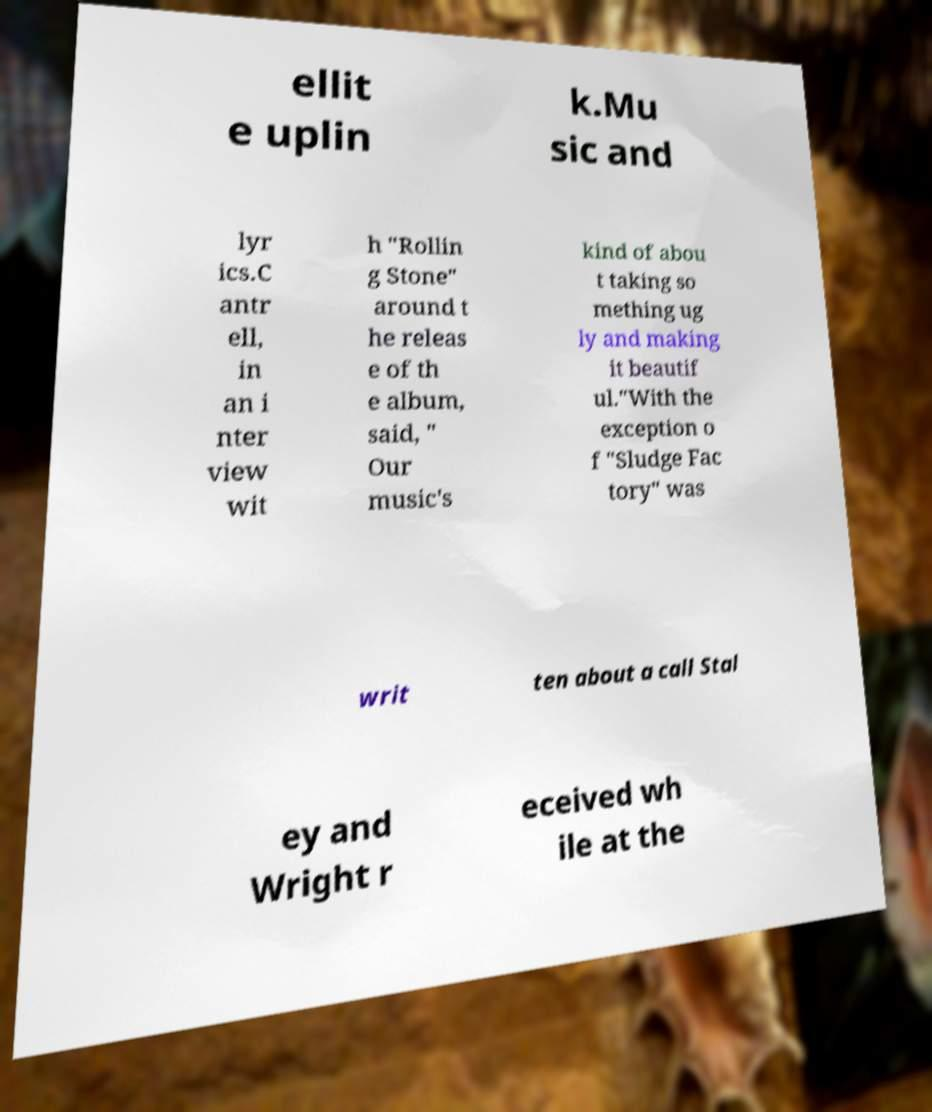Can you read and provide the text displayed in the image?This photo seems to have some interesting text. Can you extract and type it out for me? ellit e uplin k.Mu sic and lyr ics.C antr ell, in an i nter view wit h "Rollin g Stone" around t he releas e of th e album, said, " Our music's kind of abou t taking so mething ug ly and making it beautif ul."With the exception o f "Sludge Fac tory" was writ ten about a call Stal ey and Wright r eceived wh ile at the 